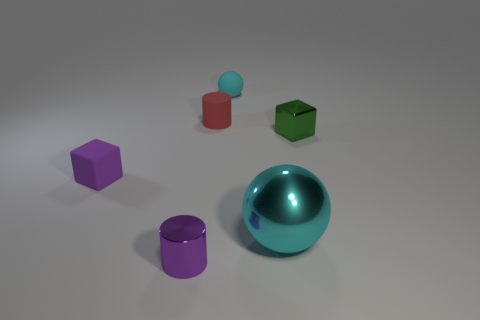There is a cylinder left of the small red matte thing; is its color the same as the small cube that is on the left side of the large cyan metal object?
Provide a succinct answer. Yes. There is another cyan object that is the same shape as the tiny cyan thing; what size is it?
Offer a very short reply. Large. Is there a small metal object of the same color as the big metallic ball?
Keep it short and to the point. No. There is a small cylinder that is the same color as the small rubber block; what is it made of?
Your answer should be very brief. Metal. What number of cubes are the same color as the shiny cylinder?
Ensure brevity in your answer.  1. What number of objects are either small green metallic objects that are in front of the matte ball or brown shiny blocks?
Ensure brevity in your answer.  1. There is a tiny cylinder that is the same material as the tiny sphere; what is its color?
Give a very brief answer. Red. Is there a metal cylinder of the same size as the cyan rubber sphere?
Offer a very short reply. Yes. What number of things are tiny cylinders in front of the small red cylinder or metal things that are to the left of the small metal cube?
Provide a short and direct response. 2. There is a cyan rubber thing that is the same size as the red thing; what is its shape?
Offer a very short reply. Sphere. 